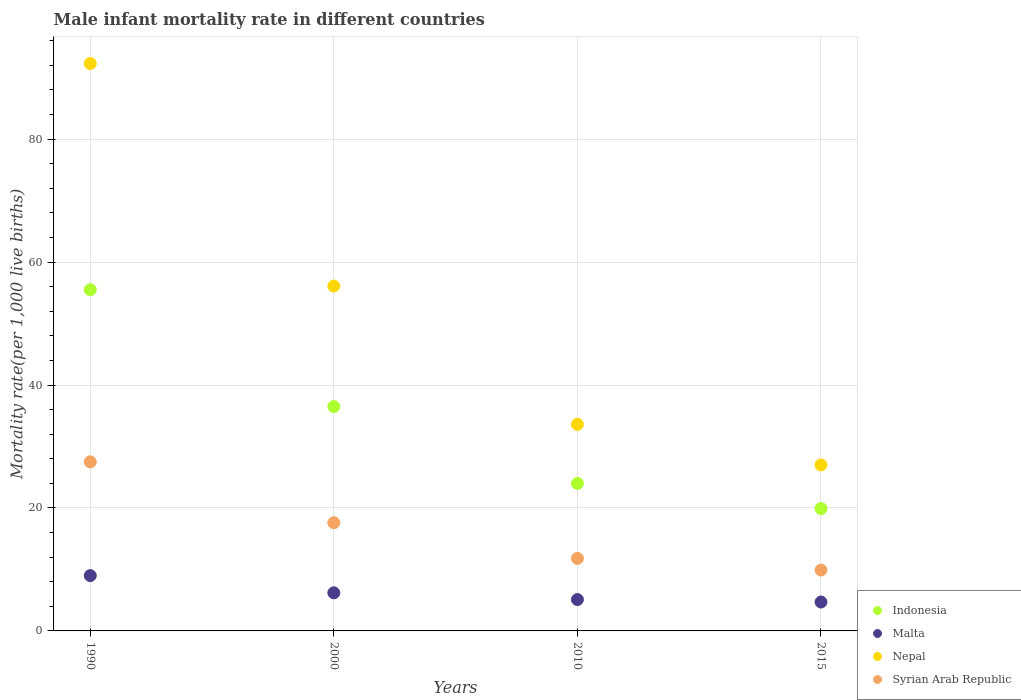How many different coloured dotlines are there?
Provide a succinct answer. 4. Across all years, what is the maximum male infant mortality rate in Nepal?
Provide a succinct answer. 92.3. In which year was the male infant mortality rate in Indonesia minimum?
Offer a very short reply. 2015. What is the total male infant mortality rate in Malta in the graph?
Keep it short and to the point. 25. What is the difference between the male infant mortality rate in Nepal in 2010 and that in 2015?
Make the answer very short. 6.6. What is the difference between the male infant mortality rate in Syrian Arab Republic in 2015 and the male infant mortality rate in Nepal in 2000?
Your answer should be very brief. -46.2. What is the average male infant mortality rate in Malta per year?
Your answer should be very brief. 6.25. In the year 1990, what is the difference between the male infant mortality rate in Indonesia and male infant mortality rate in Syrian Arab Republic?
Your response must be concise. 28. What is the ratio of the male infant mortality rate in Syrian Arab Republic in 2000 to that in 2015?
Offer a very short reply. 1.78. Is the male infant mortality rate in Indonesia in 2000 less than that in 2010?
Make the answer very short. No. What is the difference between the highest and the second highest male infant mortality rate in Indonesia?
Give a very brief answer. 19. What is the difference between the highest and the lowest male infant mortality rate in Indonesia?
Keep it short and to the point. 35.6. Is the sum of the male infant mortality rate in Indonesia in 1990 and 2015 greater than the maximum male infant mortality rate in Malta across all years?
Make the answer very short. Yes. Is it the case that in every year, the sum of the male infant mortality rate in Malta and male infant mortality rate in Nepal  is greater than the male infant mortality rate in Indonesia?
Give a very brief answer. Yes. How many years are there in the graph?
Offer a terse response. 4. What is the difference between two consecutive major ticks on the Y-axis?
Offer a very short reply. 20. Does the graph contain grids?
Make the answer very short. Yes. How many legend labels are there?
Ensure brevity in your answer.  4. What is the title of the graph?
Keep it short and to the point. Male infant mortality rate in different countries. Does "Middle East & North Africa (all income levels)" appear as one of the legend labels in the graph?
Provide a short and direct response. No. What is the label or title of the Y-axis?
Your answer should be very brief. Mortality rate(per 1,0 live births). What is the Mortality rate(per 1,000 live births) in Indonesia in 1990?
Provide a succinct answer. 55.5. What is the Mortality rate(per 1,000 live births) in Malta in 1990?
Keep it short and to the point. 9. What is the Mortality rate(per 1,000 live births) in Nepal in 1990?
Provide a short and direct response. 92.3. What is the Mortality rate(per 1,000 live births) in Syrian Arab Republic in 1990?
Your answer should be very brief. 27.5. What is the Mortality rate(per 1,000 live births) of Indonesia in 2000?
Make the answer very short. 36.5. What is the Mortality rate(per 1,000 live births) in Malta in 2000?
Provide a short and direct response. 6.2. What is the Mortality rate(per 1,000 live births) in Nepal in 2000?
Ensure brevity in your answer.  56.1. What is the Mortality rate(per 1,000 live births) of Indonesia in 2010?
Your answer should be compact. 24. What is the Mortality rate(per 1,000 live births) in Malta in 2010?
Make the answer very short. 5.1. What is the Mortality rate(per 1,000 live births) in Nepal in 2010?
Your answer should be very brief. 33.6. What is the Mortality rate(per 1,000 live births) of Syrian Arab Republic in 2010?
Provide a short and direct response. 11.8. What is the Mortality rate(per 1,000 live births) of Indonesia in 2015?
Make the answer very short. 19.9. What is the Mortality rate(per 1,000 live births) of Syrian Arab Republic in 2015?
Offer a very short reply. 9.9. Across all years, what is the maximum Mortality rate(per 1,000 live births) of Indonesia?
Offer a very short reply. 55.5. Across all years, what is the maximum Mortality rate(per 1,000 live births) in Malta?
Offer a terse response. 9. Across all years, what is the maximum Mortality rate(per 1,000 live births) in Nepal?
Make the answer very short. 92.3. Across all years, what is the minimum Mortality rate(per 1,000 live births) of Malta?
Your answer should be very brief. 4.7. Across all years, what is the minimum Mortality rate(per 1,000 live births) in Nepal?
Your answer should be very brief. 27. Across all years, what is the minimum Mortality rate(per 1,000 live births) of Syrian Arab Republic?
Provide a succinct answer. 9.9. What is the total Mortality rate(per 1,000 live births) of Indonesia in the graph?
Make the answer very short. 135.9. What is the total Mortality rate(per 1,000 live births) of Malta in the graph?
Keep it short and to the point. 25. What is the total Mortality rate(per 1,000 live births) in Nepal in the graph?
Keep it short and to the point. 209. What is the total Mortality rate(per 1,000 live births) in Syrian Arab Republic in the graph?
Offer a terse response. 66.8. What is the difference between the Mortality rate(per 1,000 live births) in Nepal in 1990 and that in 2000?
Ensure brevity in your answer.  36.2. What is the difference between the Mortality rate(per 1,000 live births) of Syrian Arab Republic in 1990 and that in 2000?
Ensure brevity in your answer.  9.9. What is the difference between the Mortality rate(per 1,000 live births) in Indonesia in 1990 and that in 2010?
Provide a short and direct response. 31.5. What is the difference between the Mortality rate(per 1,000 live births) of Nepal in 1990 and that in 2010?
Provide a short and direct response. 58.7. What is the difference between the Mortality rate(per 1,000 live births) of Indonesia in 1990 and that in 2015?
Your answer should be compact. 35.6. What is the difference between the Mortality rate(per 1,000 live births) in Nepal in 1990 and that in 2015?
Ensure brevity in your answer.  65.3. What is the difference between the Mortality rate(per 1,000 live births) in Syrian Arab Republic in 1990 and that in 2015?
Offer a very short reply. 17.6. What is the difference between the Mortality rate(per 1,000 live births) in Indonesia in 2000 and that in 2010?
Provide a short and direct response. 12.5. What is the difference between the Mortality rate(per 1,000 live births) in Syrian Arab Republic in 2000 and that in 2010?
Your response must be concise. 5.8. What is the difference between the Mortality rate(per 1,000 live births) of Indonesia in 2000 and that in 2015?
Your answer should be compact. 16.6. What is the difference between the Mortality rate(per 1,000 live births) in Nepal in 2000 and that in 2015?
Ensure brevity in your answer.  29.1. What is the difference between the Mortality rate(per 1,000 live births) of Syrian Arab Republic in 2000 and that in 2015?
Offer a terse response. 7.7. What is the difference between the Mortality rate(per 1,000 live births) of Indonesia in 2010 and that in 2015?
Give a very brief answer. 4.1. What is the difference between the Mortality rate(per 1,000 live births) in Malta in 2010 and that in 2015?
Offer a terse response. 0.4. What is the difference between the Mortality rate(per 1,000 live births) of Nepal in 2010 and that in 2015?
Make the answer very short. 6.6. What is the difference between the Mortality rate(per 1,000 live births) of Indonesia in 1990 and the Mortality rate(per 1,000 live births) of Malta in 2000?
Give a very brief answer. 49.3. What is the difference between the Mortality rate(per 1,000 live births) in Indonesia in 1990 and the Mortality rate(per 1,000 live births) in Nepal in 2000?
Provide a succinct answer. -0.6. What is the difference between the Mortality rate(per 1,000 live births) of Indonesia in 1990 and the Mortality rate(per 1,000 live births) of Syrian Arab Republic in 2000?
Your response must be concise. 37.9. What is the difference between the Mortality rate(per 1,000 live births) in Malta in 1990 and the Mortality rate(per 1,000 live births) in Nepal in 2000?
Provide a short and direct response. -47.1. What is the difference between the Mortality rate(per 1,000 live births) of Malta in 1990 and the Mortality rate(per 1,000 live births) of Syrian Arab Republic in 2000?
Offer a terse response. -8.6. What is the difference between the Mortality rate(per 1,000 live births) in Nepal in 1990 and the Mortality rate(per 1,000 live births) in Syrian Arab Republic in 2000?
Provide a short and direct response. 74.7. What is the difference between the Mortality rate(per 1,000 live births) in Indonesia in 1990 and the Mortality rate(per 1,000 live births) in Malta in 2010?
Offer a terse response. 50.4. What is the difference between the Mortality rate(per 1,000 live births) in Indonesia in 1990 and the Mortality rate(per 1,000 live births) in Nepal in 2010?
Provide a short and direct response. 21.9. What is the difference between the Mortality rate(per 1,000 live births) of Indonesia in 1990 and the Mortality rate(per 1,000 live births) of Syrian Arab Republic in 2010?
Your response must be concise. 43.7. What is the difference between the Mortality rate(per 1,000 live births) of Malta in 1990 and the Mortality rate(per 1,000 live births) of Nepal in 2010?
Offer a terse response. -24.6. What is the difference between the Mortality rate(per 1,000 live births) in Nepal in 1990 and the Mortality rate(per 1,000 live births) in Syrian Arab Republic in 2010?
Keep it short and to the point. 80.5. What is the difference between the Mortality rate(per 1,000 live births) of Indonesia in 1990 and the Mortality rate(per 1,000 live births) of Malta in 2015?
Provide a short and direct response. 50.8. What is the difference between the Mortality rate(per 1,000 live births) in Indonesia in 1990 and the Mortality rate(per 1,000 live births) in Syrian Arab Republic in 2015?
Offer a terse response. 45.6. What is the difference between the Mortality rate(per 1,000 live births) of Malta in 1990 and the Mortality rate(per 1,000 live births) of Syrian Arab Republic in 2015?
Your response must be concise. -0.9. What is the difference between the Mortality rate(per 1,000 live births) in Nepal in 1990 and the Mortality rate(per 1,000 live births) in Syrian Arab Republic in 2015?
Provide a short and direct response. 82.4. What is the difference between the Mortality rate(per 1,000 live births) in Indonesia in 2000 and the Mortality rate(per 1,000 live births) in Malta in 2010?
Provide a short and direct response. 31.4. What is the difference between the Mortality rate(per 1,000 live births) in Indonesia in 2000 and the Mortality rate(per 1,000 live births) in Syrian Arab Republic in 2010?
Offer a terse response. 24.7. What is the difference between the Mortality rate(per 1,000 live births) in Malta in 2000 and the Mortality rate(per 1,000 live births) in Nepal in 2010?
Your answer should be compact. -27.4. What is the difference between the Mortality rate(per 1,000 live births) in Nepal in 2000 and the Mortality rate(per 1,000 live births) in Syrian Arab Republic in 2010?
Your answer should be very brief. 44.3. What is the difference between the Mortality rate(per 1,000 live births) in Indonesia in 2000 and the Mortality rate(per 1,000 live births) in Malta in 2015?
Your answer should be compact. 31.8. What is the difference between the Mortality rate(per 1,000 live births) of Indonesia in 2000 and the Mortality rate(per 1,000 live births) of Syrian Arab Republic in 2015?
Ensure brevity in your answer.  26.6. What is the difference between the Mortality rate(per 1,000 live births) in Malta in 2000 and the Mortality rate(per 1,000 live births) in Nepal in 2015?
Ensure brevity in your answer.  -20.8. What is the difference between the Mortality rate(per 1,000 live births) of Malta in 2000 and the Mortality rate(per 1,000 live births) of Syrian Arab Republic in 2015?
Keep it short and to the point. -3.7. What is the difference between the Mortality rate(per 1,000 live births) in Nepal in 2000 and the Mortality rate(per 1,000 live births) in Syrian Arab Republic in 2015?
Provide a succinct answer. 46.2. What is the difference between the Mortality rate(per 1,000 live births) of Indonesia in 2010 and the Mortality rate(per 1,000 live births) of Malta in 2015?
Your answer should be compact. 19.3. What is the difference between the Mortality rate(per 1,000 live births) of Malta in 2010 and the Mortality rate(per 1,000 live births) of Nepal in 2015?
Offer a terse response. -21.9. What is the difference between the Mortality rate(per 1,000 live births) in Nepal in 2010 and the Mortality rate(per 1,000 live births) in Syrian Arab Republic in 2015?
Provide a succinct answer. 23.7. What is the average Mortality rate(per 1,000 live births) of Indonesia per year?
Ensure brevity in your answer.  33.98. What is the average Mortality rate(per 1,000 live births) in Malta per year?
Keep it short and to the point. 6.25. What is the average Mortality rate(per 1,000 live births) of Nepal per year?
Give a very brief answer. 52.25. In the year 1990, what is the difference between the Mortality rate(per 1,000 live births) in Indonesia and Mortality rate(per 1,000 live births) in Malta?
Offer a terse response. 46.5. In the year 1990, what is the difference between the Mortality rate(per 1,000 live births) in Indonesia and Mortality rate(per 1,000 live births) in Nepal?
Offer a terse response. -36.8. In the year 1990, what is the difference between the Mortality rate(per 1,000 live births) in Malta and Mortality rate(per 1,000 live births) in Nepal?
Make the answer very short. -83.3. In the year 1990, what is the difference between the Mortality rate(per 1,000 live births) in Malta and Mortality rate(per 1,000 live births) in Syrian Arab Republic?
Your answer should be very brief. -18.5. In the year 1990, what is the difference between the Mortality rate(per 1,000 live births) in Nepal and Mortality rate(per 1,000 live births) in Syrian Arab Republic?
Your answer should be very brief. 64.8. In the year 2000, what is the difference between the Mortality rate(per 1,000 live births) of Indonesia and Mortality rate(per 1,000 live births) of Malta?
Ensure brevity in your answer.  30.3. In the year 2000, what is the difference between the Mortality rate(per 1,000 live births) of Indonesia and Mortality rate(per 1,000 live births) of Nepal?
Your answer should be very brief. -19.6. In the year 2000, what is the difference between the Mortality rate(per 1,000 live births) of Indonesia and Mortality rate(per 1,000 live births) of Syrian Arab Republic?
Provide a short and direct response. 18.9. In the year 2000, what is the difference between the Mortality rate(per 1,000 live births) in Malta and Mortality rate(per 1,000 live births) in Nepal?
Provide a succinct answer. -49.9. In the year 2000, what is the difference between the Mortality rate(per 1,000 live births) of Nepal and Mortality rate(per 1,000 live births) of Syrian Arab Republic?
Ensure brevity in your answer.  38.5. In the year 2010, what is the difference between the Mortality rate(per 1,000 live births) of Indonesia and Mortality rate(per 1,000 live births) of Nepal?
Your response must be concise. -9.6. In the year 2010, what is the difference between the Mortality rate(per 1,000 live births) in Indonesia and Mortality rate(per 1,000 live births) in Syrian Arab Republic?
Provide a succinct answer. 12.2. In the year 2010, what is the difference between the Mortality rate(per 1,000 live births) of Malta and Mortality rate(per 1,000 live births) of Nepal?
Offer a terse response. -28.5. In the year 2010, what is the difference between the Mortality rate(per 1,000 live births) in Nepal and Mortality rate(per 1,000 live births) in Syrian Arab Republic?
Offer a terse response. 21.8. In the year 2015, what is the difference between the Mortality rate(per 1,000 live births) in Malta and Mortality rate(per 1,000 live births) in Nepal?
Ensure brevity in your answer.  -22.3. What is the ratio of the Mortality rate(per 1,000 live births) of Indonesia in 1990 to that in 2000?
Make the answer very short. 1.52. What is the ratio of the Mortality rate(per 1,000 live births) in Malta in 1990 to that in 2000?
Your answer should be very brief. 1.45. What is the ratio of the Mortality rate(per 1,000 live births) of Nepal in 1990 to that in 2000?
Give a very brief answer. 1.65. What is the ratio of the Mortality rate(per 1,000 live births) of Syrian Arab Republic in 1990 to that in 2000?
Keep it short and to the point. 1.56. What is the ratio of the Mortality rate(per 1,000 live births) in Indonesia in 1990 to that in 2010?
Offer a terse response. 2.31. What is the ratio of the Mortality rate(per 1,000 live births) of Malta in 1990 to that in 2010?
Your answer should be very brief. 1.76. What is the ratio of the Mortality rate(per 1,000 live births) of Nepal in 1990 to that in 2010?
Provide a short and direct response. 2.75. What is the ratio of the Mortality rate(per 1,000 live births) of Syrian Arab Republic in 1990 to that in 2010?
Your answer should be compact. 2.33. What is the ratio of the Mortality rate(per 1,000 live births) in Indonesia in 1990 to that in 2015?
Keep it short and to the point. 2.79. What is the ratio of the Mortality rate(per 1,000 live births) in Malta in 1990 to that in 2015?
Your response must be concise. 1.91. What is the ratio of the Mortality rate(per 1,000 live births) of Nepal in 1990 to that in 2015?
Make the answer very short. 3.42. What is the ratio of the Mortality rate(per 1,000 live births) in Syrian Arab Republic in 1990 to that in 2015?
Offer a terse response. 2.78. What is the ratio of the Mortality rate(per 1,000 live births) in Indonesia in 2000 to that in 2010?
Offer a terse response. 1.52. What is the ratio of the Mortality rate(per 1,000 live births) in Malta in 2000 to that in 2010?
Give a very brief answer. 1.22. What is the ratio of the Mortality rate(per 1,000 live births) of Nepal in 2000 to that in 2010?
Your response must be concise. 1.67. What is the ratio of the Mortality rate(per 1,000 live births) in Syrian Arab Republic in 2000 to that in 2010?
Keep it short and to the point. 1.49. What is the ratio of the Mortality rate(per 1,000 live births) of Indonesia in 2000 to that in 2015?
Make the answer very short. 1.83. What is the ratio of the Mortality rate(per 1,000 live births) in Malta in 2000 to that in 2015?
Keep it short and to the point. 1.32. What is the ratio of the Mortality rate(per 1,000 live births) of Nepal in 2000 to that in 2015?
Keep it short and to the point. 2.08. What is the ratio of the Mortality rate(per 1,000 live births) of Syrian Arab Republic in 2000 to that in 2015?
Provide a short and direct response. 1.78. What is the ratio of the Mortality rate(per 1,000 live births) of Indonesia in 2010 to that in 2015?
Your response must be concise. 1.21. What is the ratio of the Mortality rate(per 1,000 live births) of Malta in 2010 to that in 2015?
Offer a terse response. 1.09. What is the ratio of the Mortality rate(per 1,000 live births) in Nepal in 2010 to that in 2015?
Ensure brevity in your answer.  1.24. What is the ratio of the Mortality rate(per 1,000 live births) of Syrian Arab Republic in 2010 to that in 2015?
Ensure brevity in your answer.  1.19. What is the difference between the highest and the second highest Mortality rate(per 1,000 live births) in Indonesia?
Your answer should be compact. 19. What is the difference between the highest and the second highest Mortality rate(per 1,000 live births) of Malta?
Offer a terse response. 2.8. What is the difference between the highest and the second highest Mortality rate(per 1,000 live births) of Nepal?
Your answer should be compact. 36.2. What is the difference between the highest and the lowest Mortality rate(per 1,000 live births) of Indonesia?
Your answer should be very brief. 35.6. What is the difference between the highest and the lowest Mortality rate(per 1,000 live births) of Nepal?
Your response must be concise. 65.3. What is the difference between the highest and the lowest Mortality rate(per 1,000 live births) of Syrian Arab Republic?
Your answer should be very brief. 17.6. 